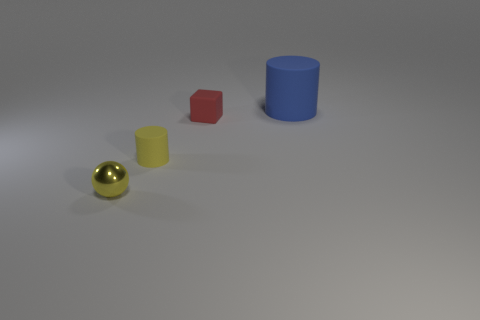Is there anything else that is the same size as the blue cylinder?
Your response must be concise. No. Is there a blue matte thing of the same size as the red matte thing?
Provide a short and direct response. No. There is a cylinder in front of the blue rubber cylinder; is its size the same as the sphere?
Give a very brief answer. Yes. How big is the red object?
Give a very brief answer. Small. What is the color of the cylinder in front of the matte cylinder that is on the right side of the matte cylinder in front of the big rubber thing?
Provide a succinct answer. Yellow. Is the color of the tiny thing in front of the yellow matte object the same as the big rubber cylinder?
Offer a very short reply. No. What number of things are in front of the small matte cube and to the right of the shiny ball?
Provide a short and direct response. 1. The other thing that is the same shape as the large matte thing is what size?
Your answer should be very brief. Small. There is a matte cylinder right of the rubber cylinder on the left side of the large blue matte thing; how many small red things are behind it?
Provide a short and direct response. 0. The tiny thing that is to the left of the rubber cylinder that is in front of the big blue object is what color?
Keep it short and to the point. Yellow. 